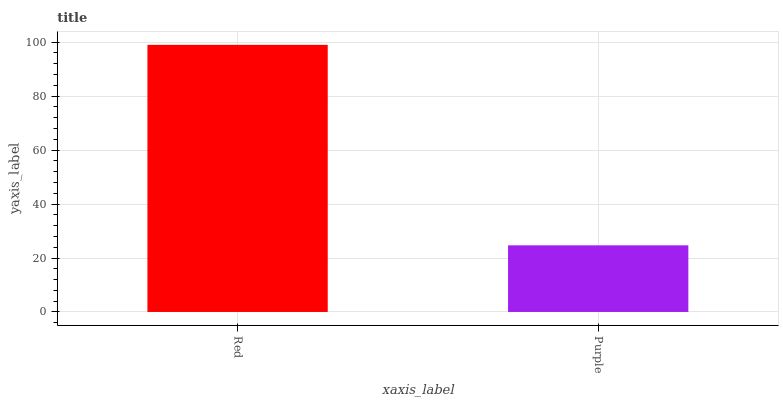Is Purple the minimum?
Answer yes or no. Yes. Is Red the maximum?
Answer yes or no. Yes. Is Purple the maximum?
Answer yes or no. No. Is Red greater than Purple?
Answer yes or no. Yes. Is Purple less than Red?
Answer yes or no. Yes. Is Purple greater than Red?
Answer yes or no. No. Is Red less than Purple?
Answer yes or no. No. Is Red the high median?
Answer yes or no. Yes. Is Purple the low median?
Answer yes or no. Yes. Is Purple the high median?
Answer yes or no. No. Is Red the low median?
Answer yes or no. No. 